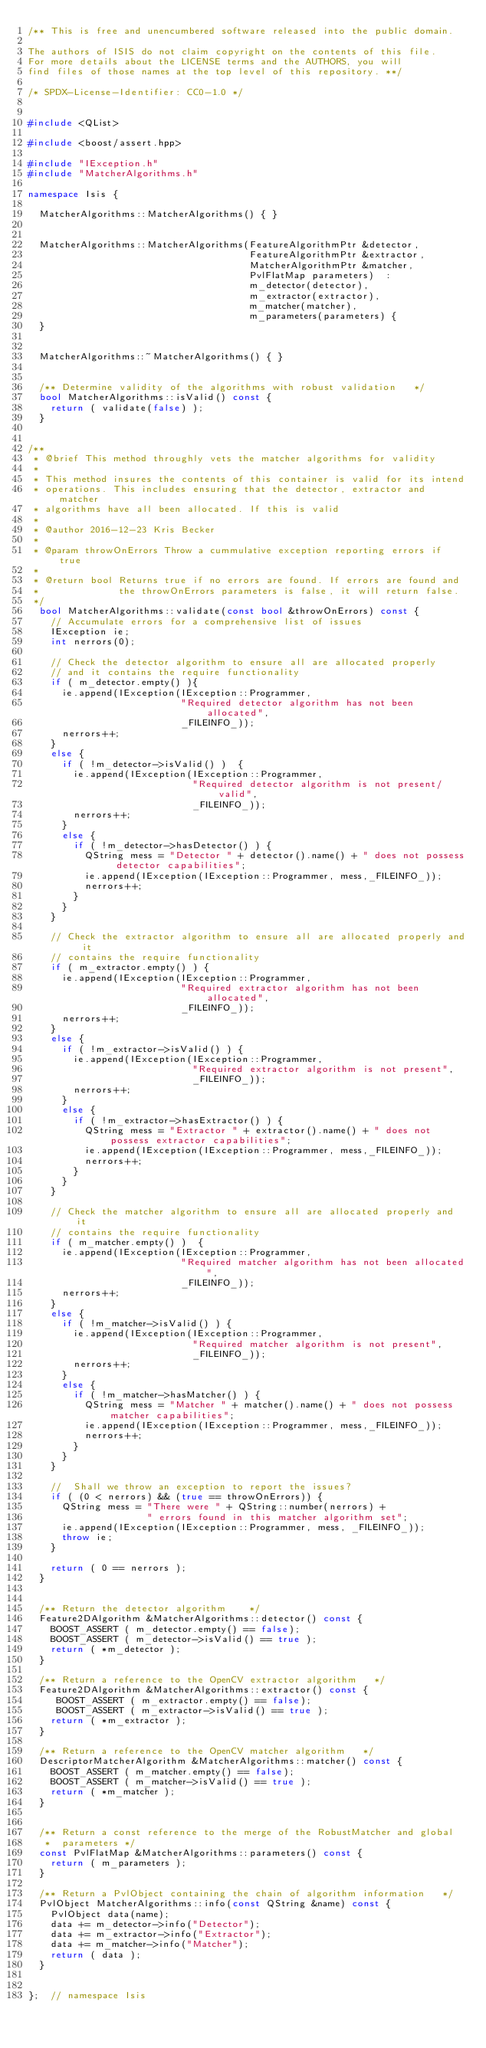Convert code to text. <code><loc_0><loc_0><loc_500><loc_500><_C++_>/** This is free and unencumbered software released into the public domain.

The authors of ISIS do not claim copyright on the contents of this file.
For more details about the LICENSE terms and the AUTHORS, you will
find files of those names at the top level of this repository. **/

/* SPDX-License-Identifier: CC0-1.0 */


#include <QList>

#include <boost/assert.hpp>

#include "IException.h"
#include "MatcherAlgorithms.h"

namespace Isis {

  MatcherAlgorithms::MatcherAlgorithms() { }


  MatcherAlgorithms::MatcherAlgorithms(FeatureAlgorithmPtr &detector,
                                       FeatureAlgorithmPtr &extractor,
                                       MatcherAlgorithmPtr &matcher,
                                       PvlFlatMap parameters)  :
                                       m_detector(detector),
                                       m_extractor(extractor),
                                       m_matcher(matcher),
                                       m_parameters(parameters) {
  }


  MatcherAlgorithms::~MatcherAlgorithms() { }


  /** Determine validity of the algorithms with robust validation   */
  bool MatcherAlgorithms::isValid() const {
    return ( validate(false) );
  }


/**
 * @brief This method throughly vets the matcher algorithms for validity
 *
 * This method insures the contents of this container is valid for its intend
 * operations. This includes ensuring that the detector, extractor and matcher
 * algorithms have all been allocated. If this is valid
 *
 * @author 2016-12-23 Kris Becker
 *
 * @param throwOnErrors Throw a cummulative exception reporting errors if true
 *
 * @return bool Returns true if no errors are found. If errors are found and
 *              the throwOnErrors parameters is false, it will return false.
 */
  bool MatcherAlgorithms::validate(const bool &throwOnErrors) const {
    // Accumulate errors for a comprehensive list of issues
    IException ie;
    int nerrors(0);

    // Check the detector algorithm to ensure all are allocated properly
    // and it contains the require functionality
    if ( m_detector.empty() ){
      ie.append(IException(IException::Programmer,
                           "Required detector algorithm has not been allocated",
                           _FILEINFO_));
      nerrors++;
    }
    else {
      if ( !m_detector->isValid() )  {
        ie.append(IException(IException::Programmer,
                             "Required detector algorithm is not present/valid",
                             _FILEINFO_));
        nerrors++;
      }
      else {
        if ( !m_detector->hasDetector() ) {
          QString mess = "Detector " + detector().name() + " does not possess detector capabilities";
          ie.append(IException(IException::Programmer, mess,_FILEINFO_));
          nerrors++;
        }
      }
    }

    // Check the extractor algorithm to ensure all are allocated properly and it
    // contains the require functionality
    if ( m_extractor.empty() ) {
      ie.append(IException(IException::Programmer,
                           "Required extractor algorithm has not been allocated",
                           _FILEINFO_));
      nerrors++;
    }
    else {
      if ( !m_extractor->isValid() ) {
        ie.append(IException(IException::Programmer,
                             "Required extractor algorithm is not present",
                             _FILEINFO_));
        nerrors++;
      }
      else {
        if ( !m_extractor->hasExtractor() ) {
          QString mess = "Extractor " + extractor().name() + " does not possess extractor capabilities";
          ie.append(IException(IException::Programmer, mess,_FILEINFO_));
          nerrors++;
        }
      }
    }

    // Check the matcher algorithm to ensure all are allocated properly and it
    // contains the require functionality
    if ( m_matcher.empty() )  {
      ie.append(IException(IException::Programmer,
                           "Required matcher algorithm has not been allocated",
                           _FILEINFO_));
      nerrors++;
    }
    else {
      if ( !m_matcher->isValid() ) {
        ie.append(IException(IException::Programmer,
                             "Required matcher algorithm is not present",
                             _FILEINFO_));
        nerrors++;
      }
      else {
        if ( !m_matcher->hasMatcher() ) {
          QString mess = "Matcher " + matcher().name() + " does not possess matcher capabilities";
          ie.append(IException(IException::Programmer, mess,_FILEINFO_));
          nerrors++;
        }
      }
    }

    //  Shall we throw an exception to report the issues?
    if ( (0 < nerrors) && (true == throwOnErrors)) {
      QString mess = "There were " + QString::number(nerrors) +
                     " errors found in this matcher algorithm set";
      ie.append(IException(IException::Programmer, mess, _FILEINFO_));
      throw ie;
    }

    return ( 0 == nerrors );
  }


  /** Return the detector algorithm    */
  Feature2DAlgorithm &MatcherAlgorithms::detector() const {
    BOOST_ASSERT ( m_detector.empty() == false);
    BOOST_ASSERT ( m_detector->isValid() == true );
    return ( *m_detector );
  }

  /** Return a reference to the OpenCV extractor algorithm   */
  Feature2DAlgorithm &MatcherAlgorithms::extractor() const {
     BOOST_ASSERT ( m_extractor.empty() == false);
     BOOST_ASSERT ( m_extractor->isValid() == true );
    return ( *m_extractor );
  }

  /** Return a reference to the OpenCV matcher algorithm   */
  DescriptorMatcherAlgorithm &MatcherAlgorithms::matcher() const {
    BOOST_ASSERT ( m_matcher.empty() == false);
    BOOST_ASSERT ( m_matcher->isValid() == true );
    return ( *m_matcher );
  }


  /** Return a const reference to the merge of the RobustMatcher and global
   *  parameters */
  const PvlFlatMap &MatcherAlgorithms::parameters() const {
    return ( m_parameters );
  }

  /** Return a PvlObject containing the chain of algorithm information   */
  PvlObject MatcherAlgorithms::info(const QString &name) const {
    PvlObject data(name);
    data += m_detector->info("Detector");
    data += m_extractor->info("Extractor");
    data += m_matcher->info("Matcher");
    return ( data );
  }


};  // namespace Isis
</code> 